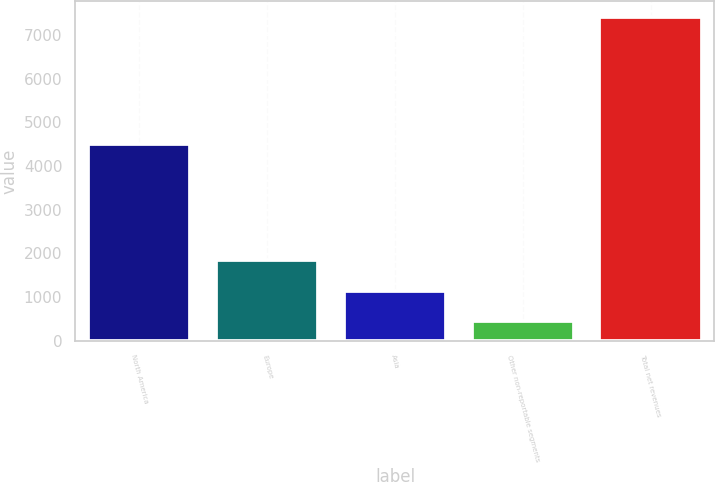Convert chart. <chart><loc_0><loc_0><loc_500><loc_500><bar_chart><fcel>North America<fcel>Europe<fcel>Asia<fcel>Other non-reportable segments<fcel>Total net revenues<nl><fcel>4493.9<fcel>1845.84<fcel>1150.92<fcel>456<fcel>7405.2<nl></chart> 